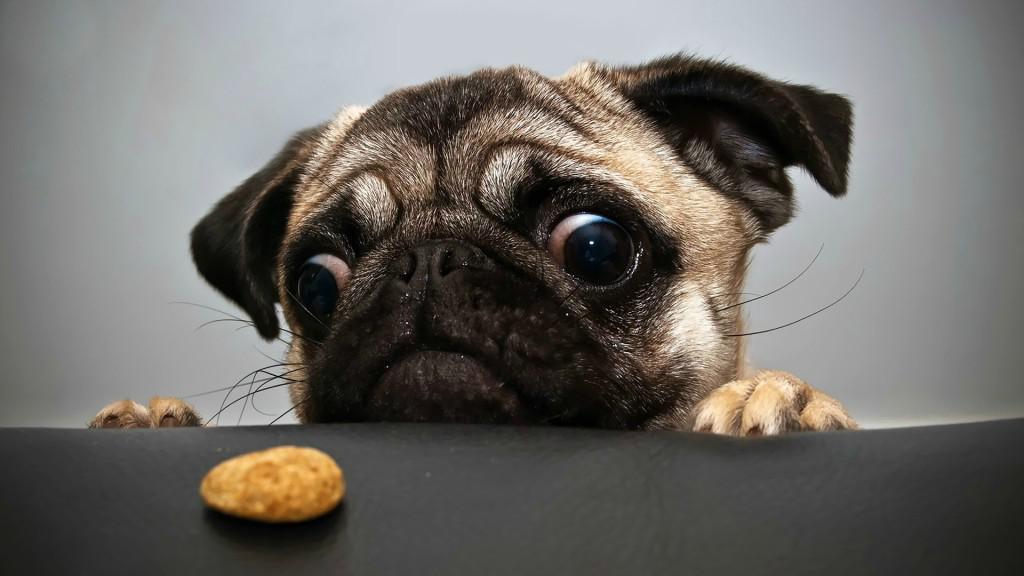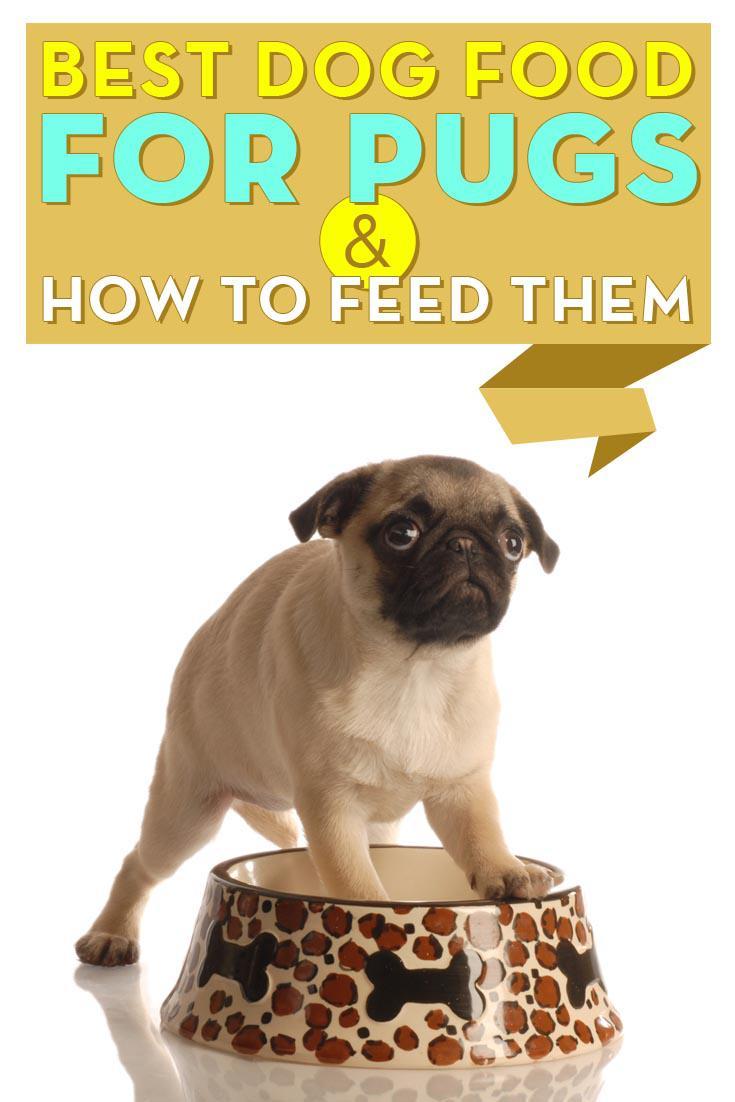The first image is the image on the left, the second image is the image on the right. For the images displayed, is the sentence "An image shows one pug dog with one pet food bowl." factually correct? Answer yes or no. Yes. 